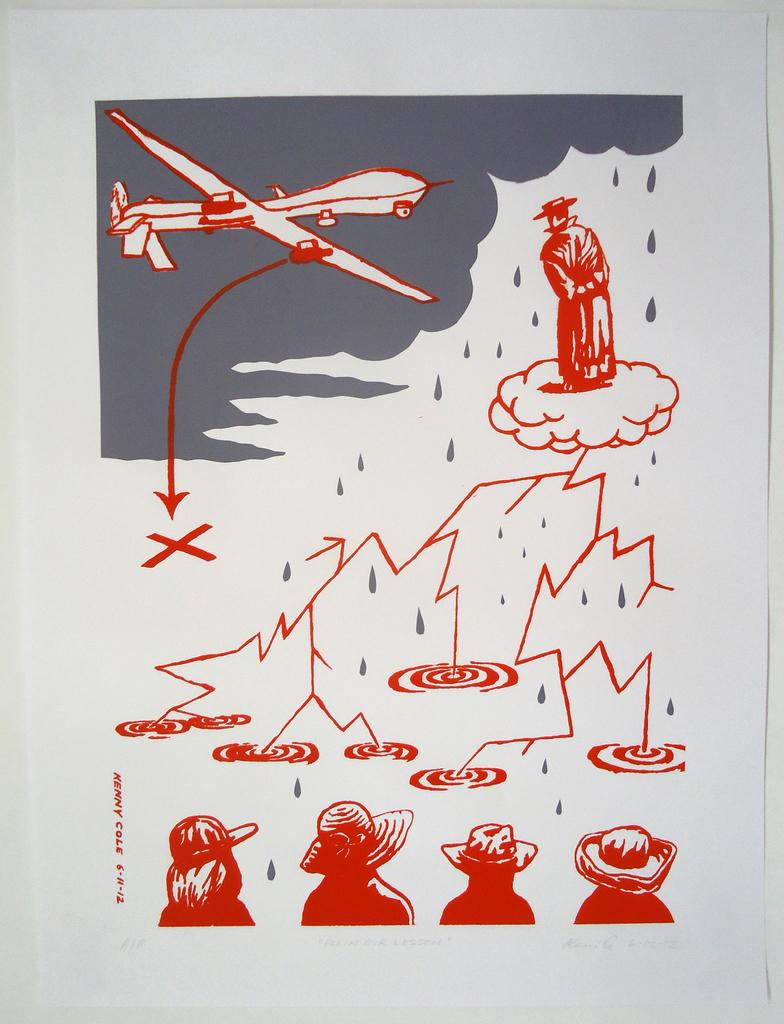Who or what can be seen in the image? There are people in the image. What else is present in the image besides the people? There is an aircraft in the image. What is the color of the paper on which the image is printed? The image is on a white color paper. What is the color of the background in the image? The background of the image is in white color. What type of spade is being used to stir the stew in the image? There is no spade or stew present in the image. How many spoons are visible in the image? There are no spoons visible in the image. 